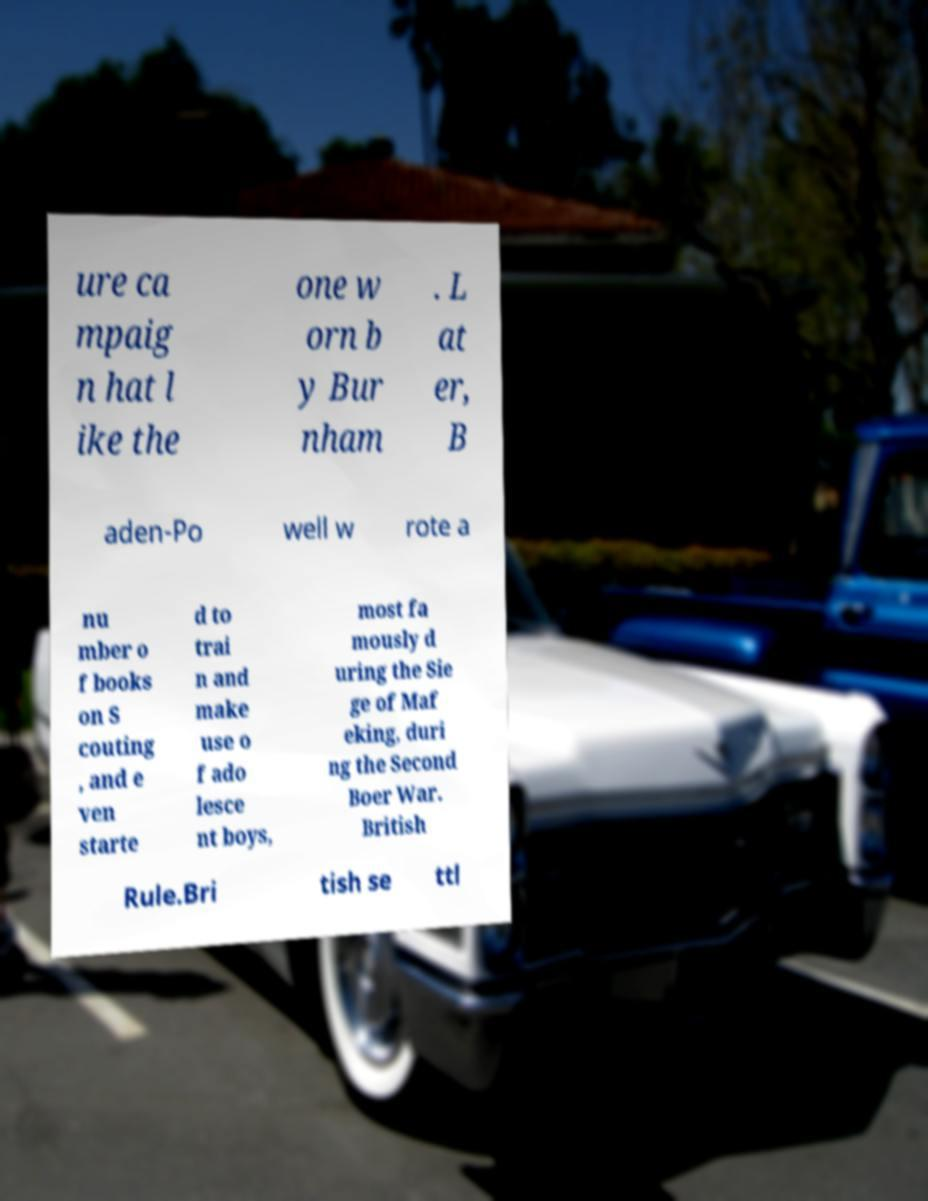For documentation purposes, I need the text within this image transcribed. Could you provide that? ure ca mpaig n hat l ike the one w orn b y Bur nham . L at er, B aden-Po well w rote a nu mber o f books on S couting , and e ven starte d to trai n and make use o f ado lesce nt boys, most fa mously d uring the Sie ge of Maf eking, duri ng the Second Boer War. British Rule.Bri tish se ttl 